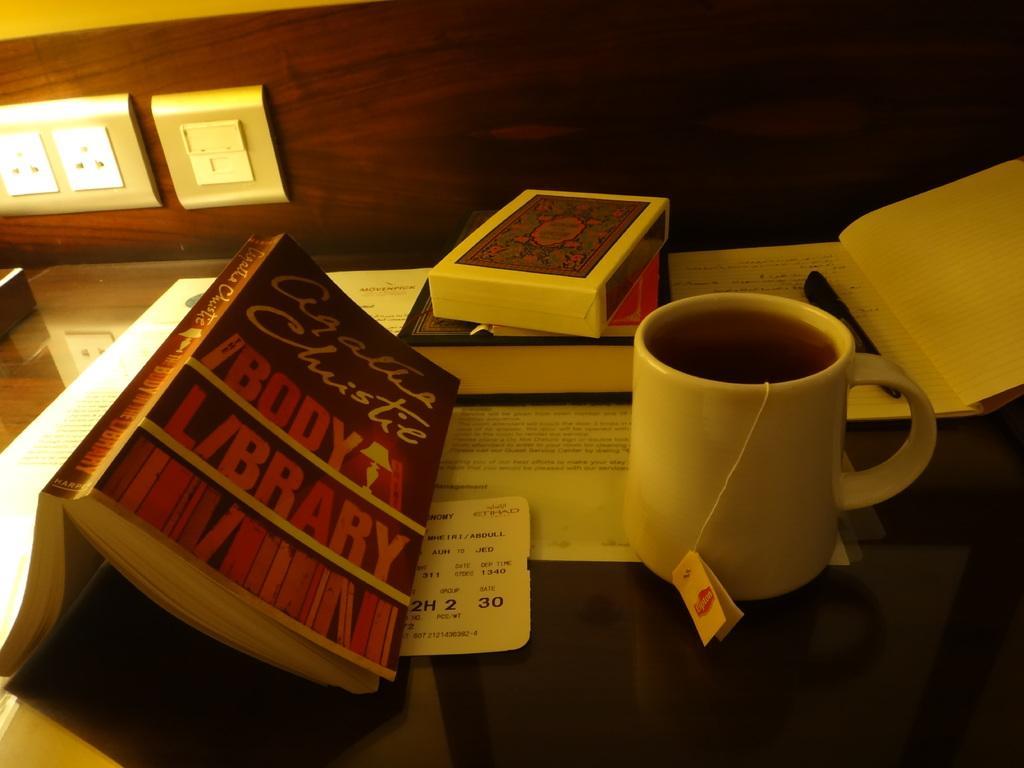In one or two sentences, can you explain what this image depicts? In this image I can see a table, few books, box and tea mug, one pen are placed. In the background I can see a switch board one switch board attached to the wall. 